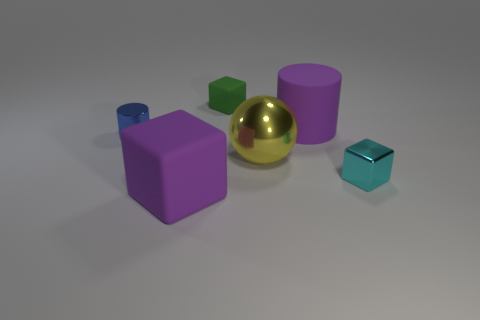Subtract all matte cubes. How many cubes are left? 1 Add 4 small blue balls. How many objects exist? 10 Subtract all blue blocks. Subtract all gray spheres. How many blocks are left? 3 Subtract all big purple matte cubes. Subtract all tiny cyan cubes. How many objects are left? 4 Add 6 big rubber things. How many big rubber things are left? 8 Add 3 yellow metal spheres. How many yellow metal spheres exist? 4 Subtract 1 blue cylinders. How many objects are left? 5 Subtract all spheres. How many objects are left? 5 